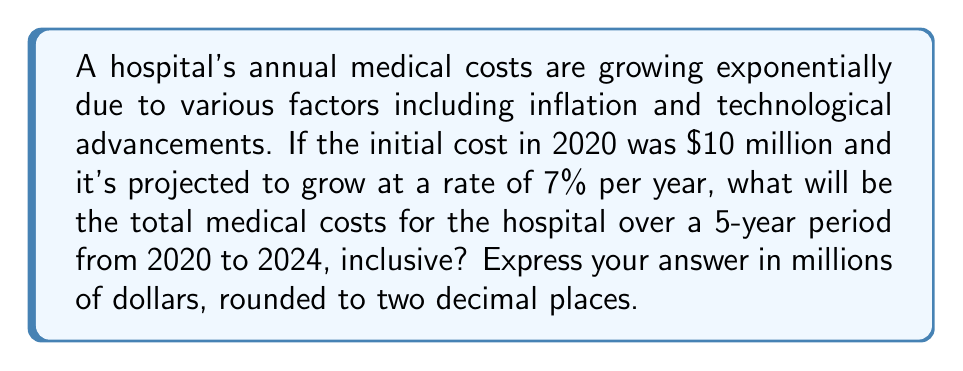Can you solve this math problem? To solve this problem, we need to use the formula for exponential growth and sum the costs for each year. Let's break it down step-by-step:

1) The exponential growth formula is:
   $A = P(1 + r)^t$
   Where:
   $A$ = Amount after growth
   $P$ = Principal (initial amount)
   $r$ = Growth rate (as a decimal)
   $t$ = Time (in years)

2) We have:
   $P = 10$ million
   $r = 0.07$ (7% expressed as a decimal)
   We need to calculate for $t = 0, 1, 2, 3, 4$ (representing 2020 to 2024)

3) Let's calculate the cost for each year:

   2020 ($t=0$): $A_0 = 10(1 + 0.07)^0 = 10$ million
   2021 ($t=1$): $A_1 = 10(1 + 0.07)^1 = 10.70$ million
   2022 ($t=2$): $A_2 = 10(1 + 0.07)^2 = 11.45$ million
   2023 ($t=3$): $A_3 = 10(1 + 0.07)^3 = 12.25$ million
   2024 ($t=4$): $A_4 = 10(1 + 0.07)^4 = 13.11$ million

4) To get the total cost over the 5-year period, we sum these values:

   $\text{Total Cost} = A_0 + A_1 + A_2 + A_3 + A_4$
   $= 10 + 10.70 + 11.45 + 12.25 + 13.11$
   $= 57.51$ million

Therefore, the total medical costs for the hospital over the 5-year period from 2020 to 2024, inclusive, will be $57.51 million.
Answer: $57.51 million 